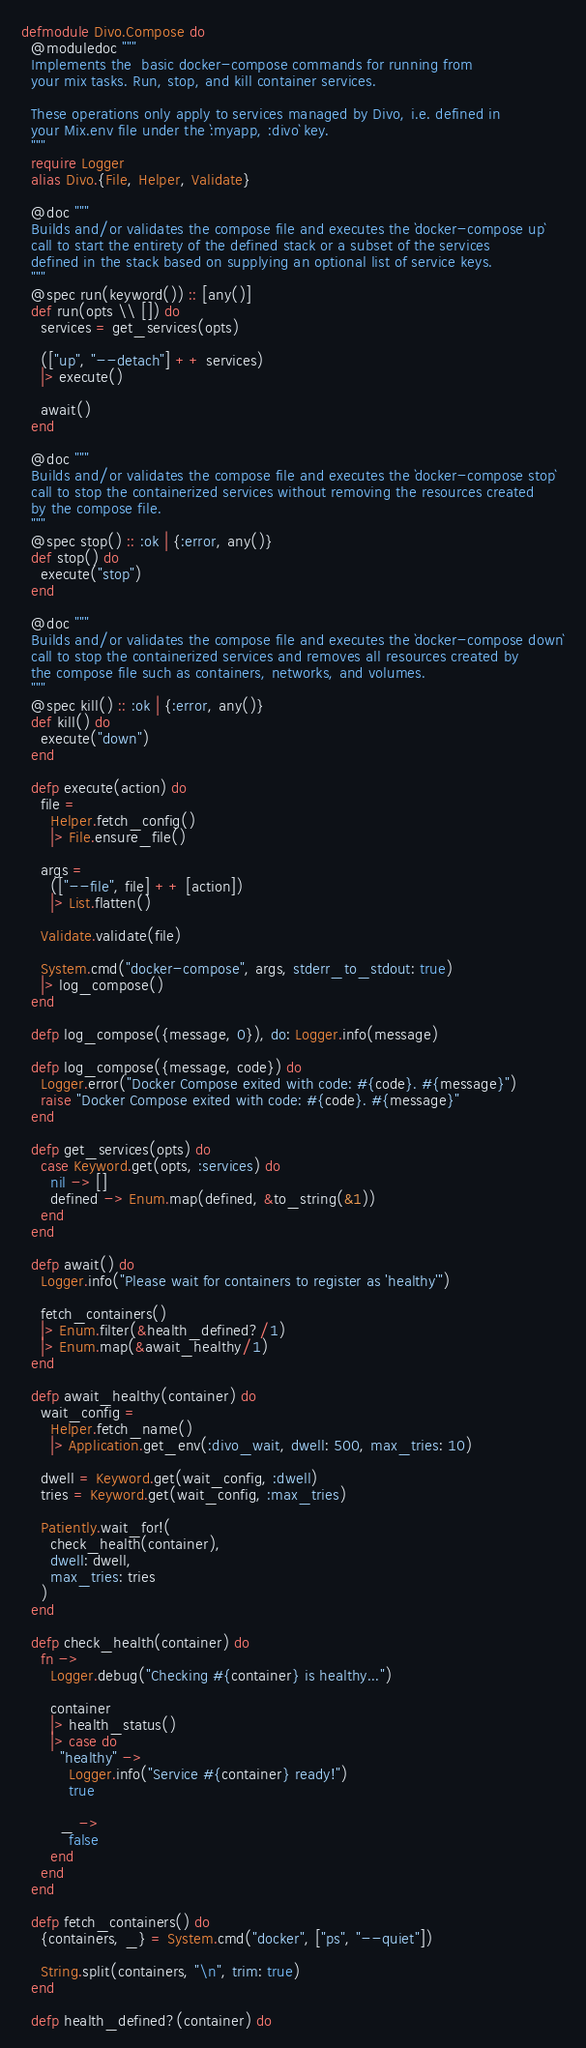<code> <loc_0><loc_0><loc_500><loc_500><_Elixir_>defmodule Divo.Compose do
  @moduledoc """
  Implements the  basic docker-compose commands for running from
  your mix tasks. Run, stop, and kill container services.

  These operations only apply to services managed by Divo, i.e. defined in
  your Mix.env file under the `:myapp, :divo` key.
  """
  require Logger
  alias Divo.{File, Helper, Validate}

  @doc """
  Builds and/or validates the compose file and executes the `docker-compose up`
  call to start the entirety of the defined stack or a subset of the services
  defined in the stack based on supplying an optional list of service keys.
  """
  @spec run(keyword()) :: [any()]
  def run(opts \\ []) do
    services = get_services(opts)

    (["up", "--detach"] ++ services)
    |> execute()

    await()
  end

  @doc """
  Builds and/or validates the compose file and executes the `docker-compose stop`
  call to stop the containerized services without removing the resources created
  by the compose file.
  """
  @spec stop() :: :ok | {:error, any()}
  def stop() do
    execute("stop")
  end

  @doc """
  Builds and/or validates the compose file and executes the `docker-compose down`
  call to stop the containerized services and removes all resources created by
  the compose file such as containers, networks, and volumes.
  """
  @spec kill() :: :ok | {:error, any()}
  def kill() do
    execute("down")
  end

  defp execute(action) do
    file =
      Helper.fetch_config()
      |> File.ensure_file()

    args =
      (["--file", file] ++ [action])
      |> List.flatten()

    Validate.validate(file)

    System.cmd("docker-compose", args, stderr_to_stdout: true)
    |> log_compose()
  end

  defp log_compose({message, 0}), do: Logger.info(message)

  defp log_compose({message, code}) do
    Logger.error("Docker Compose exited with code: #{code}. #{message}")
    raise "Docker Compose exited with code: #{code}. #{message}"
  end

  defp get_services(opts) do
    case Keyword.get(opts, :services) do
      nil -> []
      defined -> Enum.map(defined, &to_string(&1))
    end
  end

  defp await() do
    Logger.info("Please wait for containers to register as 'healthy'")

    fetch_containers()
    |> Enum.filter(&health_defined?/1)
    |> Enum.map(&await_healthy/1)
  end

  defp await_healthy(container) do
    wait_config =
      Helper.fetch_name()
      |> Application.get_env(:divo_wait, dwell: 500, max_tries: 10)

    dwell = Keyword.get(wait_config, :dwell)
    tries = Keyword.get(wait_config, :max_tries)

    Patiently.wait_for!(
      check_health(container),
      dwell: dwell,
      max_tries: tries
    )
  end

  defp check_health(container) do
    fn ->
      Logger.debug("Checking #{container} is healthy...")

      container
      |> health_status()
      |> case do
        "healthy" ->
          Logger.info("Service #{container} ready!")
          true

        _ ->
          false
      end
    end
  end

  defp fetch_containers() do
    {containers, _} = System.cmd("docker", ["ps", "--quiet"])

    String.split(containers, "\n", trim: true)
  end

  defp health_defined?(container) do</code> 